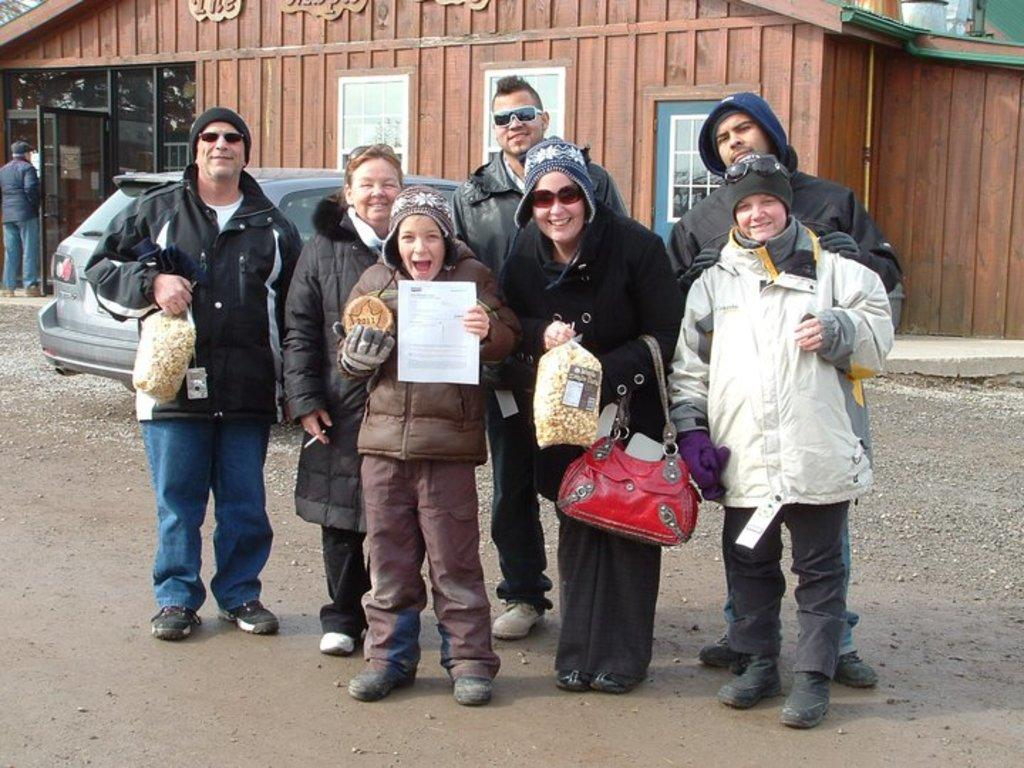What type of structure is visible in the image? There is a house in the image. What part of the house can be seen in the image? There is a window in the image. What mode of transportation is present in the image? There is a car in the image. Who or what is present in the image besides the house, window, and car? There are people in the image. What type of camp can be seen in the image? There is no camp present in the image; it features a house, window, car, and people. Are there any police officers visible in the image? There is no mention of police officers in the image, as it only includes a house, window, car, and people. 